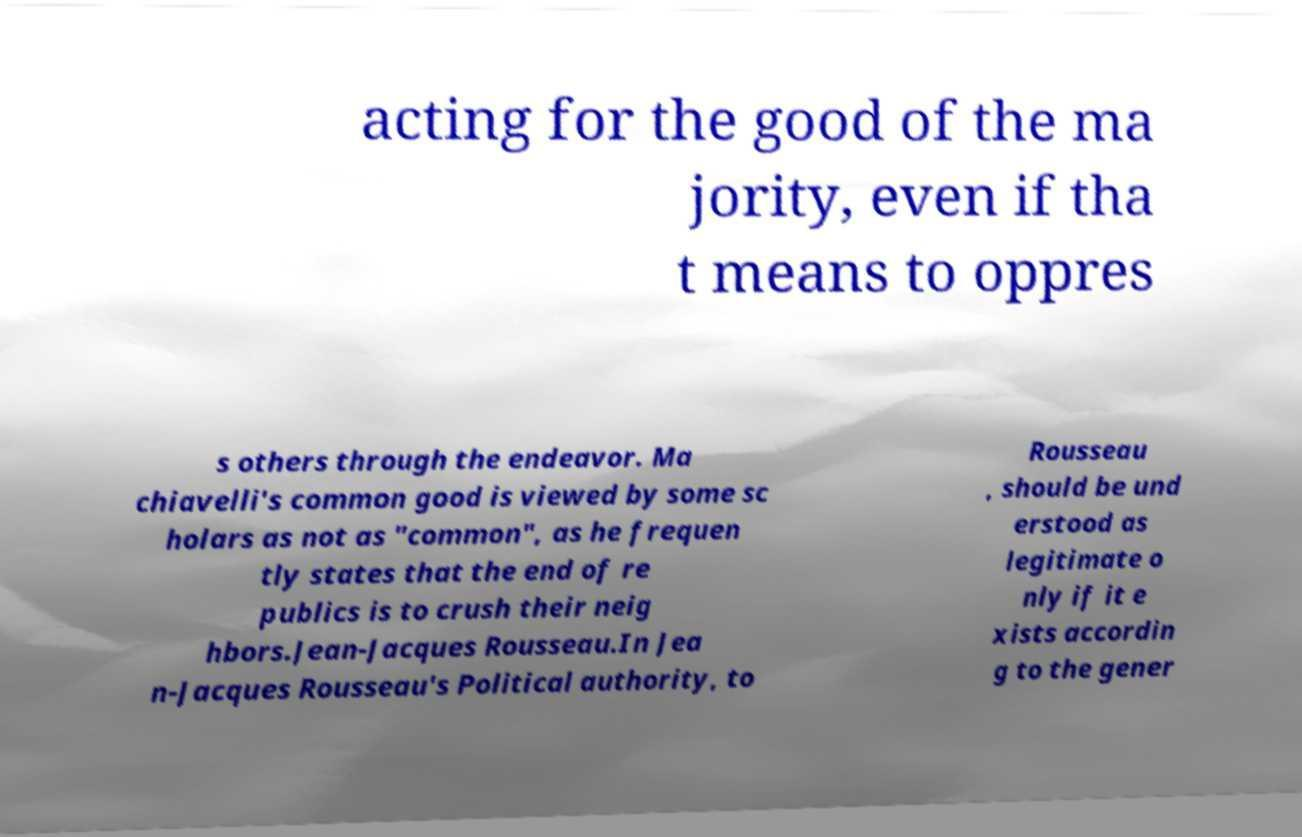What messages or text are displayed in this image? I need them in a readable, typed format. acting for the good of the ma jority, even if tha t means to oppres s others through the endeavor. Ma chiavelli's common good is viewed by some sc holars as not as "common", as he frequen tly states that the end of re publics is to crush their neig hbors.Jean-Jacques Rousseau.In Jea n-Jacques Rousseau's Political authority, to Rousseau , should be und erstood as legitimate o nly if it e xists accordin g to the gener 